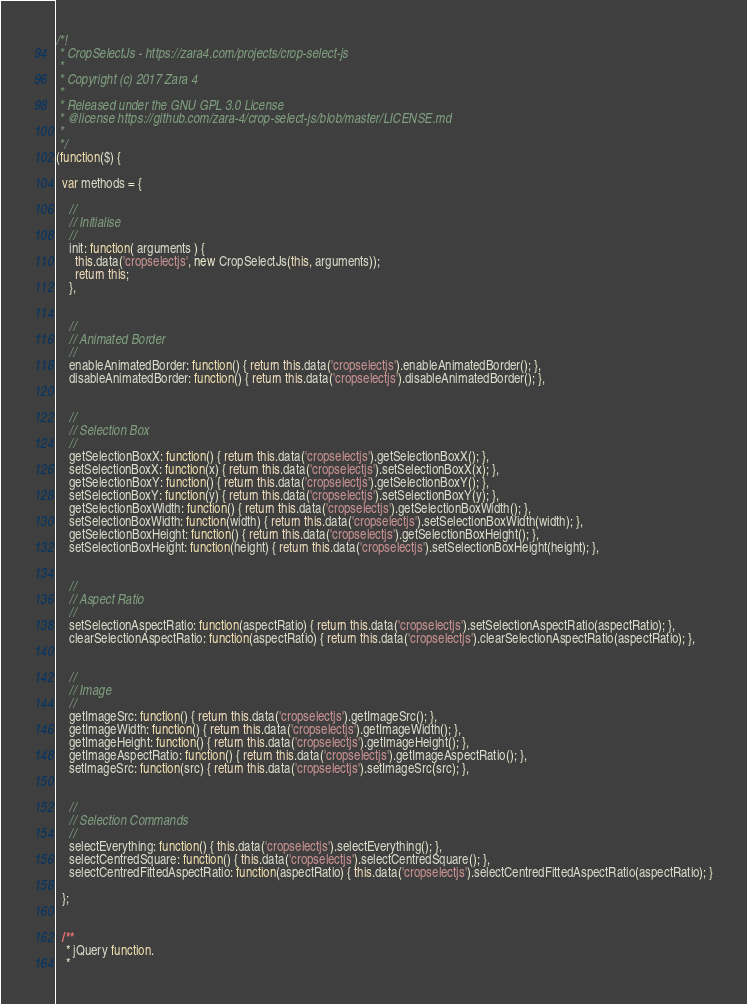Convert code to text. <code><loc_0><loc_0><loc_500><loc_500><_JavaScript_>/*!
 * CropSelectJs - https://zara4.com/projects/crop-select-js
 *
 * Copyright (c) 2017 Zara 4
 *
 * Released under the GNU GPL 3.0 License
 * @license https://github.com/zara-4/crop-select-js/blob/master/LICENSE.md
 *
 */
(function($) {

  var methods = {

    //
    // Initialise
    //
    init: function( arguments ) {
      this.data('cropselectjs', new CropSelectJs(this, arguments));
      return this;
    },


    //
    // Animated Border
    //
    enableAnimatedBorder: function() { return this.data('cropselectjs').enableAnimatedBorder(); },
    disableAnimatedBorder: function() { return this.data('cropselectjs').disableAnimatedBorder(); },


    //
    // Selection Box
    //
    getSelectionBoxX: function() { return this.data('cropselectjs').getSelectionBoxX(); },
    setSelectionBoxX: function(x) { return this.data('cropselectjs').setSelectionBoxX(x); },
    getSelectionBoxY: function() { return this.data('cropselectjs').getSelectionBoxY(); },
    setSelectionBoxY: function(y) { return this.data('cropselectjs').setSelectionBoxY(y); },
    getSelectionBoxWidth: function() { return this.data('cropselectjs').getSelectionBoxWidth(); },
    setSelectionBoxWidth: function(width) { return this.data('cropselectjs').setSelectionBoxWidth(width); },
    getSelectionBoxHeight: function() { return this.data('cropselectjs').getSelectionBoxHeight(); },
    setSelectionBoxHeight: function(height) { return this.data('cropselectjs').setSelectionBoxHeight(height); },


    //
    // Aspect Ratio
    //
    setSelectionAspectRatio: function(aspectRatio) { return this.data('cropselectjs').setSelectionAspectRatio(aspectRatio); },
    clearSelectionAspectRatio: function(aspectRatio) { return this.data('cropselectjs').clearSelectionAspectRatio(aspectRatio); },


    //
    // Image
    //
    getImageSrc: function() { return this.data('cropselectjs').getImageSrc(); },
    getImageWidth: function() { return this.data('cropselectjs').getImageWidth(); },
    getImageHeight: function() { return this.data('cropselectjs').getImageHeight(); },
    getImageAspectRatio: function() { return this.data('cropselectjs').getImageAspectRatio(); },
    setImageSrc: function(src) { return this.data('cropselectjs').setImageSrc(src); },


    //
    // Selection Commands
    //
    selectEverything: function() { this.data('cropselectjs').selectEverything(); },
    selectCentredSquare: function() { this.data('cropselectjs').selectCentredSquare(); },
    selectCentredFittedAspectRatio: function(aspectRatio) { this.data('cropselectjs').selectCentredFittedAspectRatio(aspectRatio); }

  };


  /**
   * jQuery function.
   *</code> 